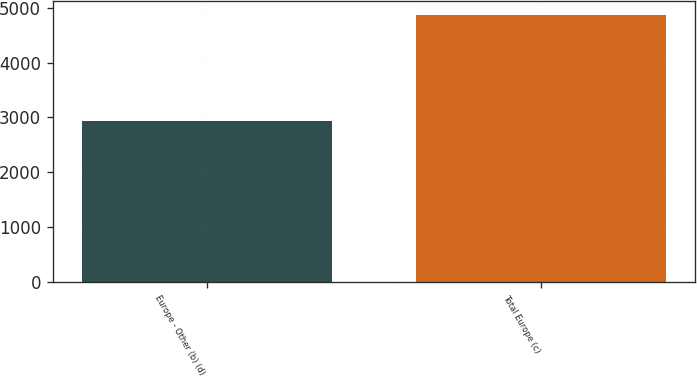Convert chart. <chart><loc_0><loc_0><loc_500><loc_500><bar_chart><fcel>Europe - Other (b) (d)<fcel>Total Europe (c)<nl><fcel>2932<fcel>4877<nl></chart> 